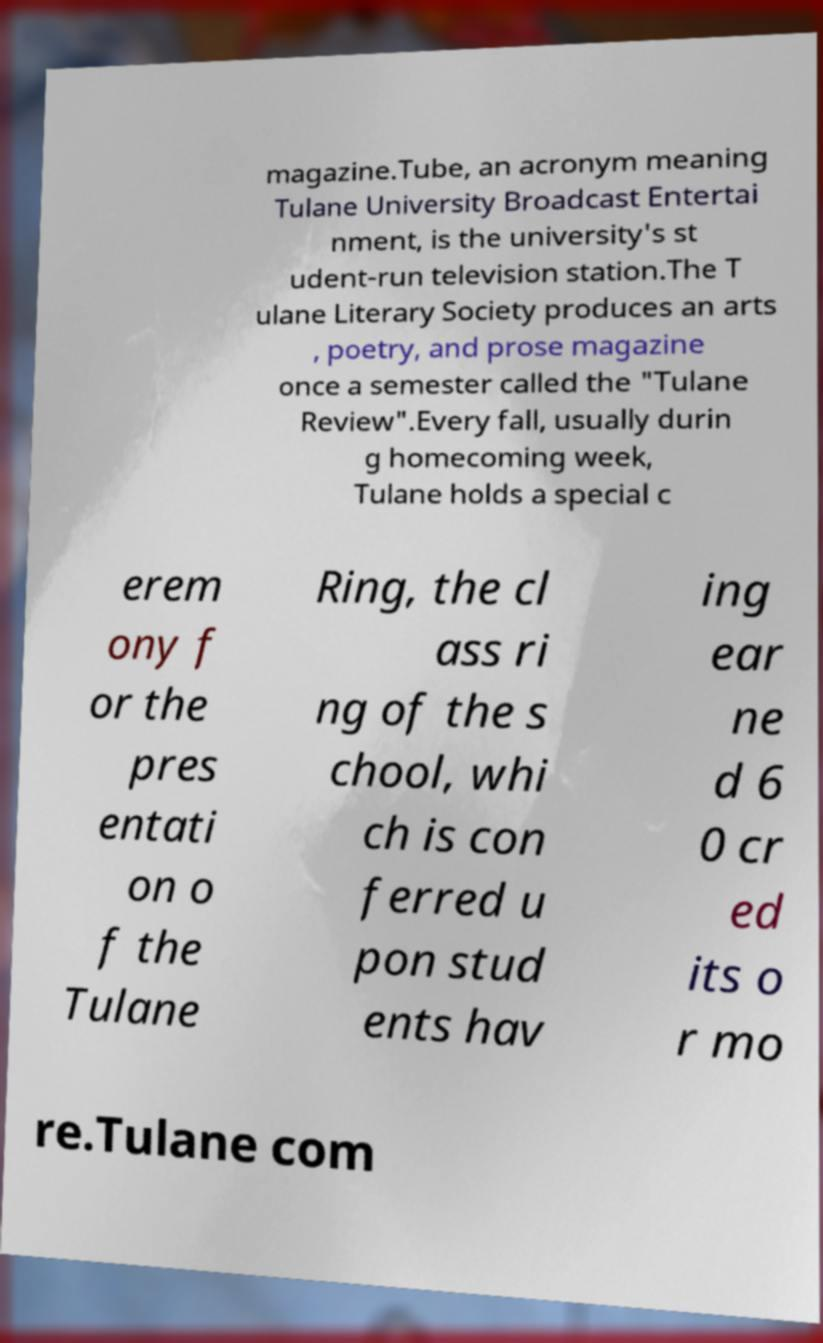I need the written content from this picture converted into text. Can you do that? magazine.Tube, an acronym meaning Tulane University Broadcast Entertai nment, is the university's st udent-run television station.The T ulane Literary Society produces an arts , poetry, and prose magazine once a semester called the "Tulane Review".Every fall, usually durin g homecoming week, Tulane holds a special c erem ony f or the pres entati on o f the Tulane Ring, the cl ass ri ng of the s chool, whi ch is con ferred u pon stud ents hav ing ear ne d 6 0 cr ed its o r mo re.Tulane com 